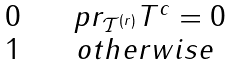<formula> <loc_0><loc_0><loc_500><loc_500>\begin{matrix} \ 0 & \ & \ p r _ { \mathcal { T } ^ { ( r ) } } T ^ { c } = 0 \\ \ 1 & \ & o t h e r w i s e \end{matrix}</formula> 